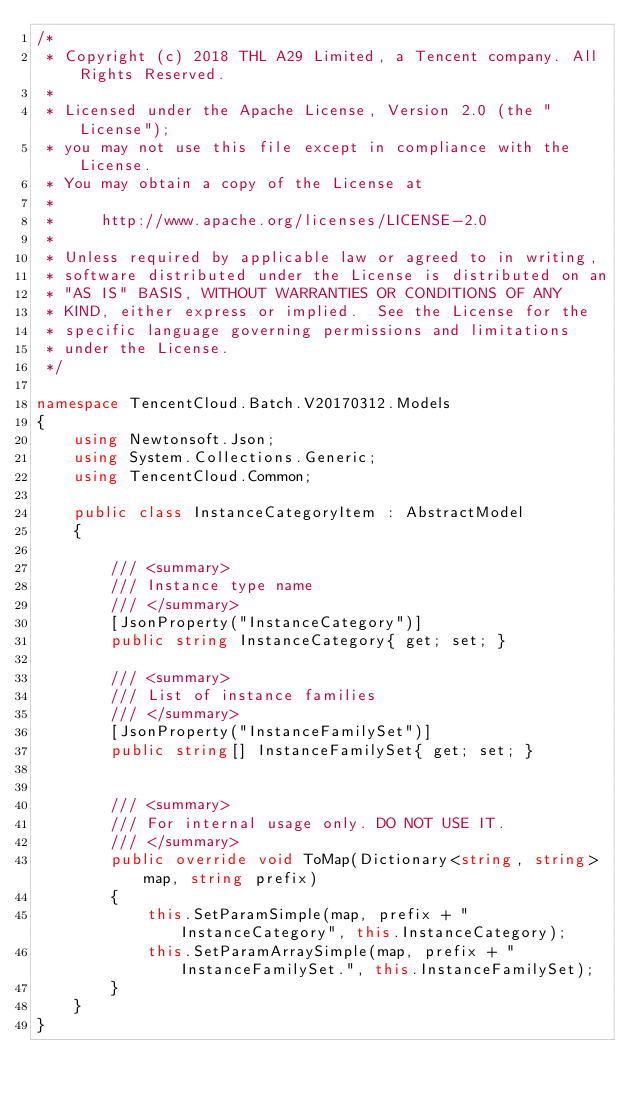<code> <loc_0><loc_0><loc_500><loc_500><_C#_>/*
 * Copyright (c) 2018 THL A29 Limited, a Tencent company. All Rights Reserved.
 *
 * Licensed under the Apache License, Version 2.0 (the "License");
 * you may not use this file except in compliance with the License.
 * You may obtain a copy of the License at
 *
 *     http://www.apache.org/licenses/LICENSE-2.0
 *
 * Unless required by applicable law or agreed to in writing,
 * software distributed under the License is distributed on an
 * "AS IS" BASIS, WITHOUT WARRANTIES OR CONDITIONS OF ANY
 * KIND, either express or implied.  See the License for the
 * specific language governing permissions and limitations
 * under the License.
 */

namespace TencentCloud.Batch.V20170312.Models
{
    using Newtonsoft.Json;
    using System.Collections.Generic;
    using TencentCloud.Common;

    public class InstanceCategoryItem : AbstractModel
    {
        
        /// <summary>
        /// Instance type name
        /// </summary>
        [JsonProperty("InstanceCategory")]
        public string InstanceCategory{ get; set; }

        /// <summary>
        /// List of instance families
        /// </summary>
        [JsonProperty("InstanceFamilySet")]
        public string[] InstanceFamilySet{ get; set; }


        /// <summary>
        /// For internal usage only. DO NOT USE IT.
        /// </summary>
        public override void ToMap(Dictionary<string, string> map, string prefix)
        {
            this.SetParamSimple(map, prefix + "InstanceCategory", this.InstanceCategory);
            this.SetParamArraySimple(map, prefix + "InstanceFamilySet.", this.InstanceFamilySet);
        }
    }
}

</code> 